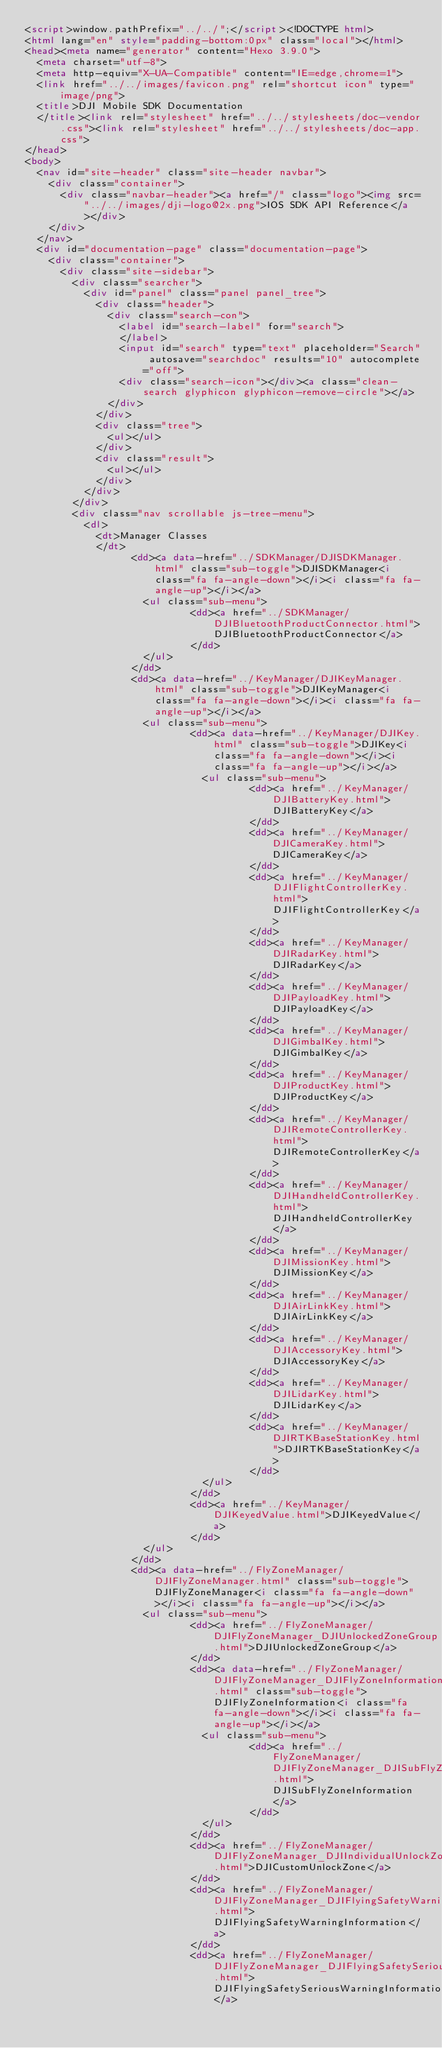<code> <loc_0><loc_0><loc_500><loc_500><_HTML_><script>window.pathPrefix="../../";</script><!DOCTYPE html>
<html lang="en" style="padding-bottom:0px" class="local"></html>
<head><meta name="generator" content="Hexo 3.9.0">
  <meta charset="utf-8">
  <meta http-equiv="X-UA-Compatible" content="IE=edge,chrome=1">
  <link href="../../images/favicon.png" rel="shortcut icon" type="image/png">
  <title>DJI Mobile SDK Documentation
  </title><link rel="stylesheet" href="../../stylesheets/doc-vendor.css"><link rel="stylesheet" href="../../stylesheets/doc-app.css">
</head>
<body>
  <nav id="site-header" class="site-header navbar">
    <div class="container">
      <div class="navbar-header"><a href="/" class="logo"><img src="../../images/dji-logo@2x.png">IOS SDK API Reference</a></div>
    </div>
  </nav>
  <div id="documentation-page" class="documentation-page">
    <div class="container">
      <div class="site-sidebar">
        <div class="searcher">
          <div id="panel" class="panel panel_tree">
            <div class="header">
              <div class="search-con">
                <label id="search-label" for="search">
                </label>
                <input id="search" type="text" placeholder="Search" autosave="searchdoc" results="10" autocomplete="off">
                <div class="search-icon"></div><a class="clean-search glyphicon glyphicon-remove-circle"></a>
              </div>
            </div>
            <div class="tree">
              <ul></ul>
            </div>
            <div class="result">
              <ul></ul>
            </div>
          </div>
        </div>
        <div class="nav scrollable js-tree-menu">
          <dl>
            <dt>Manager Classes
            </dt>
                  <dd><a data-href="../SDKManager/DJISDKManager.html" class="sub-toggle">DJISDKManager<i class="fa fa-angle-down"></i><i class="fa fa-angle-up"></i></a>
                    <ul class="sub-menu">
                            <dd><a href="../SDKManager/DJIBluetoothProductConnector.html">DJIBluetoothProductConnector</a>
                            </dd>
                    </ul>
                  </dd>
                  <dd><a data-href="../KeyManager/DJIKeyManager.html" class="sub-toggle">DJIKeyManager<i class="fa fa-angle-down"></i><i class="fa fa-angle-up"></i></a>
                    <ul class="sub-menu">
                            <dd><a data-href="../KeyManager/DJIKey.html" class="sub-toggle">DJIKey<i class="fa fa-angle-down"></i><i class="fa fa-angle-up"></i></a>
                              <ul class="sub-menu">
                                      <dd><a href="../KeyManager/DJIBatteryKey.html">DJIBatteryKey</a>
                                      </dd>
                                      <dd><a href="../KeyManager/DJICameraKey.html">DJICameraKey</a>
                                      </dd>
                                      <dd><a href="../KeyManager/DJIFlightControllerKey.html">DJIFlightControllerKey</a>
                                      </dd>
                                      <dd><a href="../KeyManager/DJIRadarKey.html">DJIRadarKey</a>
                                      </dd>
                                      <dd><a href="../KeyManager/DJIPayloadKey.html">DJIPayloadKey</a>
                                      </dd>
                                      <dd><a href="../KeyManager/DJIGimbalKey.html">DJIGimbalKey</a>
                                      </dd>
                                      <dd><a href="../KeyManager/DJIProductKey.html">DJIProductKey</a>
                                      </dd>
                                      <dd><a href="../KeyManager/DJIRemoteControllerKey.html">DJIRemoteControllerKey</a>
                                      </dd>
                                      <dd><a href="../KeyManager/DJIHandheldControllerKey.html">DJIHandheldControllerKey</a>
                                      </dd>
                                      <dd><a href="../KeyManager/DJIMissionKey.html">DJIMissionKey</a>
                                      </dd>
                                      <dd><a href="../KeyManager/DJIAirLinkKey.html">DJIAirLinkKey</a>
                                      </dd>
                                      <dd><a href="../KeyManager/DJIAccessoryKey.html">DJIAccessoryKey</a>
                                      </dd>
                                      <dd><a href="../KeyManager/DJILidarKey.html">DJILidarKey</a>
                                      </dd>
                                      <dd><a href="../KeyManager/DJIRTKBaseStationKey.html">DJIRTKBaseStationKey</a>
                                      </dd>
                              </ul>
                            </dd>
                            <dd><a href="../KeyManager/DJIKeyedValue.html">DJIKeyedValue</a>
                            </dd>
                    </ul>
                  </dd>
                  <dd><a data-href="../FlyZoneManager/DJIFlyZoneManager.html" class="sub-toggle">DJIFlyZoneManager<i class="fa fa-angle-down"></i><i class="fa fa-angle-up"></i></a>
                    <ul class="sub-menu">
                            <dd><a href="../FlyZoneManager/DJIFlyZoneManager_DJIUnlockedZoneGroup.html">DJIUnlockedZoneGroup</a>
                            </dd>
                            <dd><a data-href="../FlyZoneManager/DJIFlyZoneManager_DJIFlyZoneInformation.html" class="sub-toggle">DJIFlyZoneInformation<i class="fa fa-angle-down"></i><i class="fa fa-angle-up"></i></a>
                              <ul class="sub-menu">
                                      <dd><a href="../FlyZoneManager/DJIFlyZoneManager_DJISubFlyZoneInformation.html">DJISubFlyZoneInformation</a>
                                      </dd>
                              </ul>
                            </dd>
                            <dd><a href="../FlyZoneManager/DJIFlyZoneManager_DJIIndividualUnlockZone.html">DJICustomUnlockZone</a>
                            </dd>
                            <dd><a href="../FlyZoneManager/DJIFlyZoneManager_DJIFlyingSafetyWarningInformation.html">DJIFlyingSafetyWarningInformation</a>
                            </dd>
                            <dd><a href="../FlyZoneManager/DJIFlyZoneManager_DJIFlyingSafetySeriousWarningInformation.html">DJIFlyingSafetySeriousWarningInformation</a></code> 